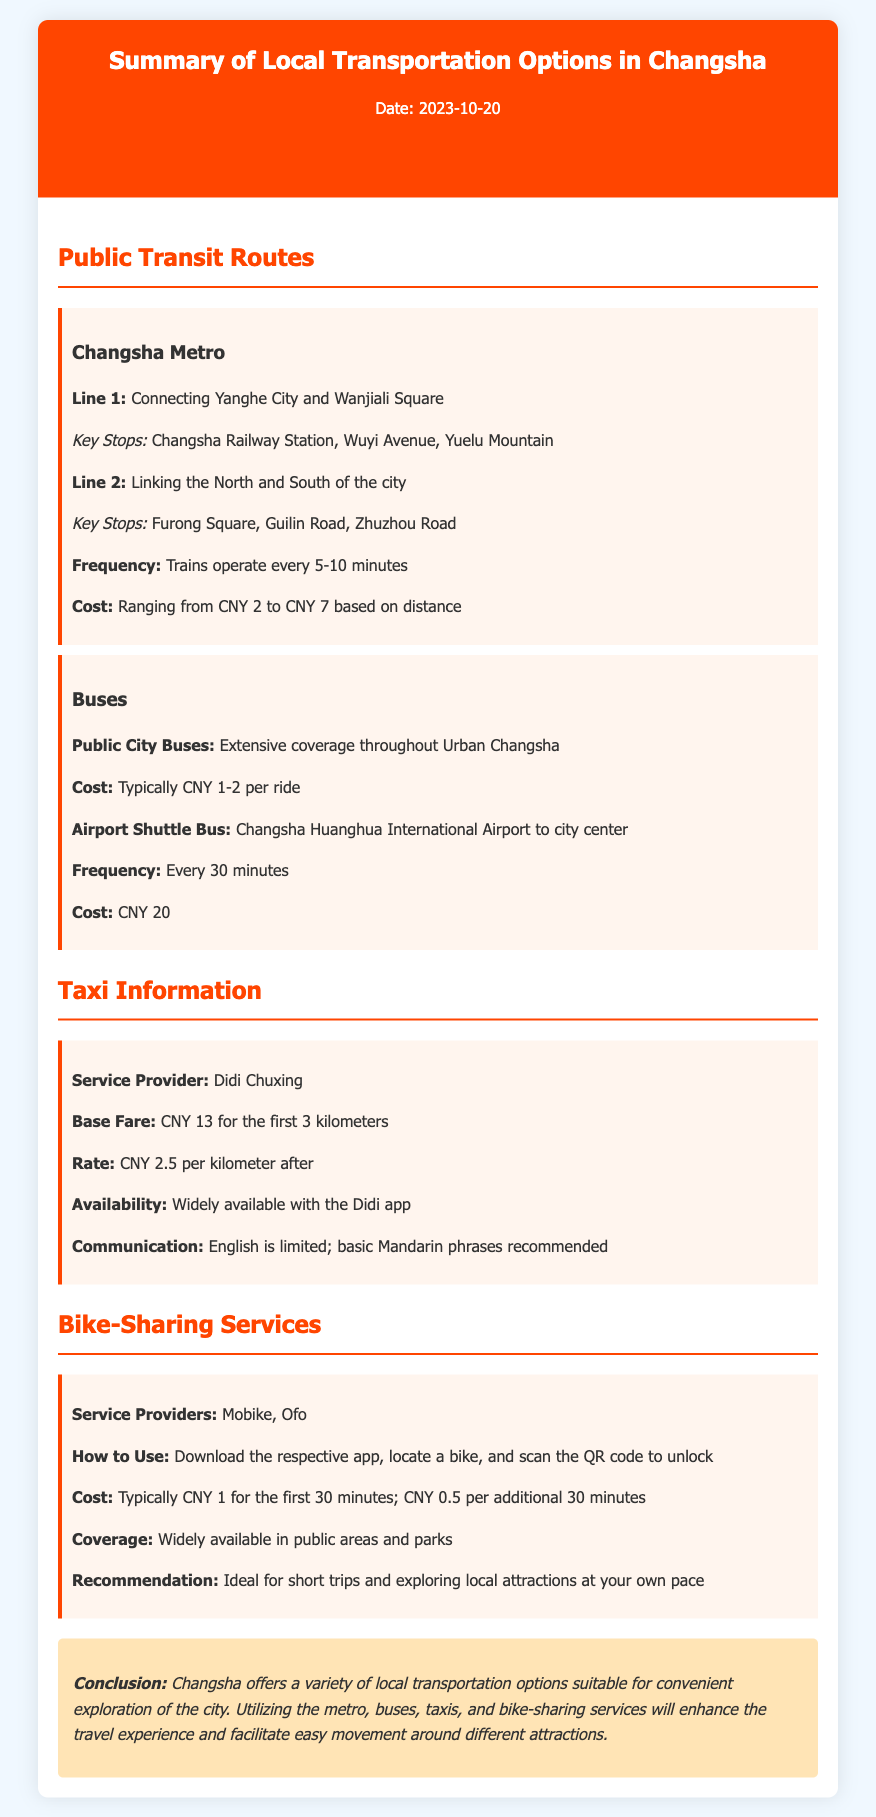What are the two main lines of the Changsha Metro? The document lists two main lines of the Metro, Line 1 and Line 2.
Answer: Line 1, Line 2 What is the frequency of metro trains? The frequency of trains is stated in the document.
Answer: Every 5-10 minutes What is the cost per ride for city buses? The document specifies the cost of city bus rides.
Answer: CNY 1-2 What is the base fare for taxis? The document mentions the initial fare for taxis.
Answer: CNY 13 Which app is recommended for taxi services? The document identifies the app used for taxi services.
Answer: Didi Chuxing How much does an airport shuttle cost? The document provides the cost of the airport shuttle bus.
Answer: CNY 20 What is the cost for the first 30 minutes of bike-sharing? The document explains the pricing for bike-sharing services.
Answer: CNY 1 Which service providers are listed for bike-sharing? The document mentions the bike-sharing services available in Changsha.
Answer: Mobike, Ofo What is a key recommendation for bike-sharing? The document offers a recommendation regarding bike-sharing usage.
Answer: Ideal for short trips 